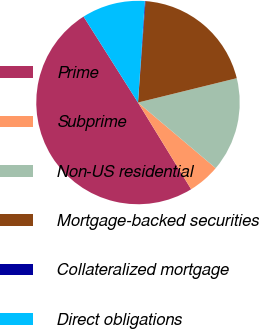Convert chart. <chart><loc_0><loc_0><loc_500><loc_500><pie_chart><fcel>Prime<fcel>Subprime<fcel>Non-US residential<fcel>Mortgage-backed securities<fcel>Collateralized mortgage<fcel>Direct obligations<nl><fcel>49.77%<fcel>5.08%<fcel>15.01%<fcel>19.98%<fcel>0.11%<fcel>10.05%<nl></chart> 